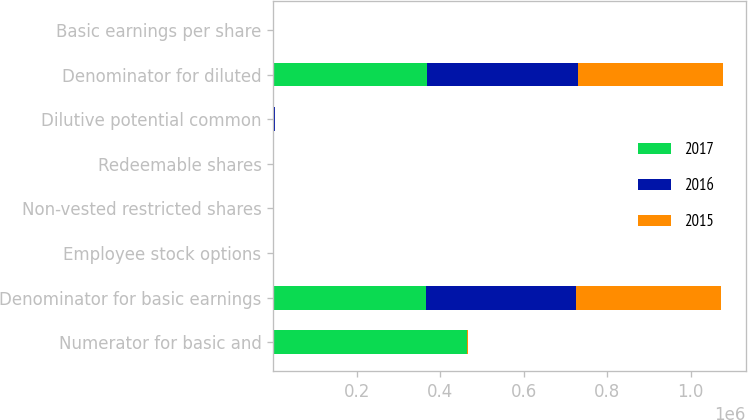Convert chart. <chart><loc_0><loc_0><loc_500><loc_500><stacked_bar_chart><ecel><fcel>Numerator for basic and<fcel>Denominator for basic earnings<fcel>Employee stock options<fcel>Non-vested restricted shares<fcel>Redeemable shares<fcel>Dilutive potential common<fcel>Denominator for diluted<fcel>Basic earnings per share<nl><fcel>2017<fcel>463595<fcel>367237<fcel>47<fcel>482<fcel>1235<fcel>1764<fcel>369001<fcel>1.26<nl><fcel>2016<fcel>1209.5<fcel>358275<fcel>110<fcel>449<fcel>1393<fcel>1952<fcel>360227<fcel>2.83<nl><fcel>2015<fcel>1209.5<fcel>348240<fcel>143<fcel>535<fcel>310<fcel>1184<fcel>349424<fcel>2.35<nl></chart> 